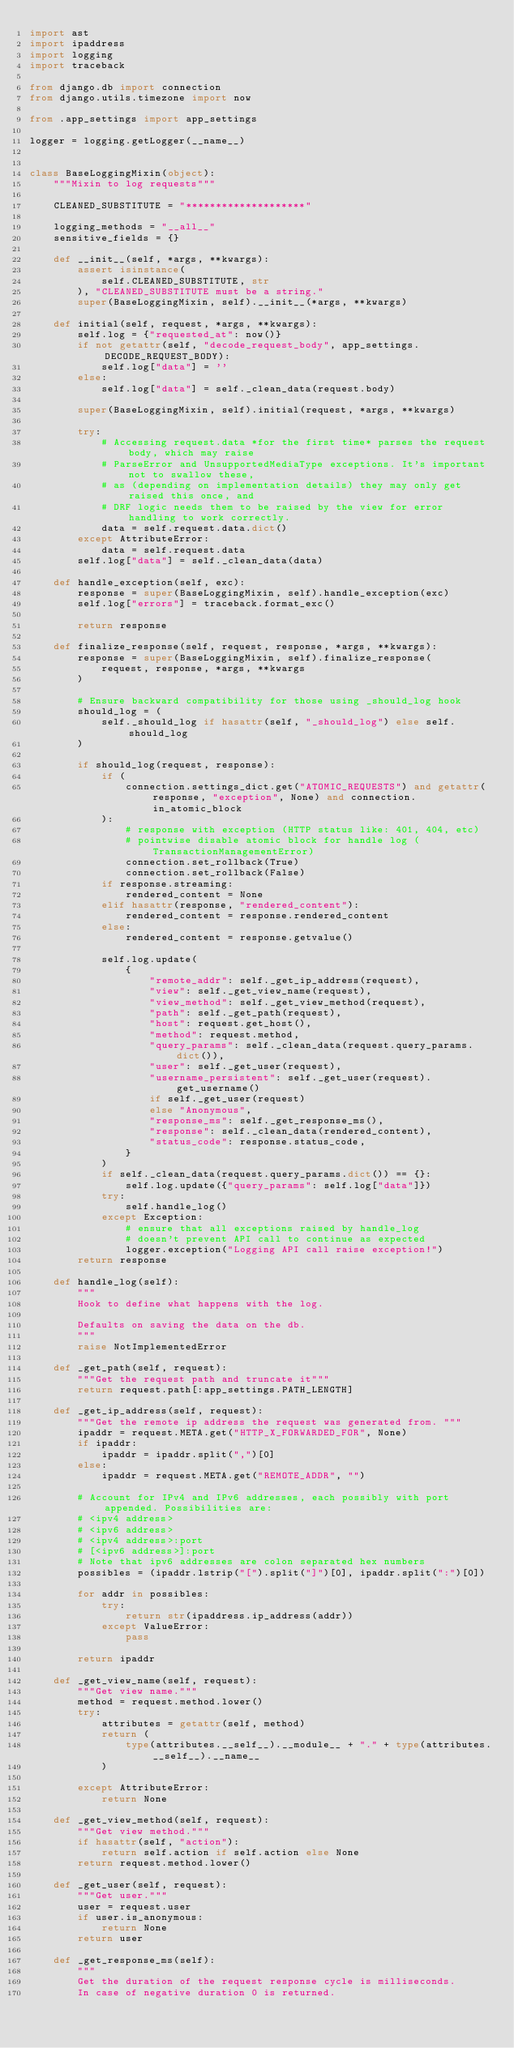<code> <loc_0><loc_0><loc_500><loc_500><_Python_>import ast
import ipaddress
import logging
import traceback

from django.db import connection
from django.utils.timezone import now

from .app_settings import app_settings

logger = logging.getLogger(__name__)


class BaseLoggingMixin(object):
    """Mixin to log requests"""

    CLEANED_SUBSTITUTE = "********************"

    logging_methods = "__all__"
    sensitive_fields = {}

    def __init__(self, *args, **kwargs):
        assert isinstance(
            self.CLEANED_SUBSTITUTE, str
        ), "CLEANED_SUBSTITUTE must be a string."
        super(BaseLoggingMixin, self).__init__(*args, **kwargs)

    def initial(self, request, *args, **kwargs):
        self.log = {"requested_at": now()}
        if not getattr(self, "decode_request_body", app_settings.DECODE_REQUEST_BODY):
            self.log["data"] = ''
        else:
            self.log["data"] = self._clean_data(request.body)

        super(BaseLoggingMixin, self).initial(request, *args, **kwargs)

        try:
            # Accessing request.data *for the first time* parses the request body, which may raise
            # ParseError and UnsupportedMediaType exceptions. It's important not to swallow these,
            # as (depending on implementation details) they may only get raised this once, and
            # DRF logic needs them to be raised by the view for error handling to work correctly.
            data = self.request.data.dict()
        except AttributeError:
            data = self.request.data
        self.log["data"] = self._clean_data(data)

    def handle_exception(self, exc):
        response = super(BaseLoggingMixin, self).handle_exception(exc)
        self.log["errors"] = traceback.format_exc()

        return response

    def finalize_response(self, request, response, *args, **kwargs):
        response = super(BaseLoggingMixin, self).finalize_response(
            request, response, *args, **kwargs
        )

        # Ensure backward compatibility for those using _should_log hook
        should_log = (
            self._should_log if hasattr(self, "_should_log") else self.should_log
        )

        if should_log(request, response):
            if (
                connection.settings_dict.get("ATOMIC_REQUESTS") and getattr(response, "exception", None) and connection.in_atomic_block
            ):
                # response with exception (HTTP status like: 401, 404, etc)
                # pointwise disable atomic block for handle log (TransactionManagementError)
                connection.set_rollback(True)
                connection.set_rollback(False)
            if response.streaming:
                rendered_content = None
            elif hasattr(response, "rendered_content"):
                rendered_content = response.rendered_content
            else:
                rendered_content = response.getvalue()

            self.log.update(
                {
                    "remote_addr": self._get_ip_address(request),
                    "view": self._get_view_name(request),
                    "view_method": self._get_view_method(request),
                    "path": self._get_path(request),
                    "host": request.get_host(),
                    "method": request.method,
                    "query_params": self._clean_data(request.query_params.dict()),
                    "user": self._get_user(request),
                    "username_persistent": self._get_user(request).get_username()
                    if self._get_user(request)
                    else "Anonymous",
                    "response_ms": self._get_response_ms(),
                    "response": self._clean_data(rendered_content),
                    "status_code": response.status_code,
                }
            )
            if self._clean_data(request.query_params.dict()) == {}:
                self.log.update({"query_params": self.log["data"]})
            try:
                self.handle_log()
            except Exception:
                # ensure that all exceptions raised by handle_log
                # doesn't prevent API call to continue as expected
                logger.exception("Logging API call raise exception!")
        return response

    def handle_log(self):
        """
        Hook to define what happens with the log.

        Defaults on saving the data on the db.
        """
        raise NotImplementedError

    def _get_path(self, request):
        """Get the request path and truncate it"""
        return request.path[:app_settings.PATH_LENGTH]

    def _get_ip_address(self, request):
        """Get the remote ip address the request was generated from. """
        ipaddr = request.META.get("HTTP_X_FORWARDED_FOR", None)
        if ipaddr:
            ipaddr = ipaddr.split(",")[0]
        else:
            ipaddr = request.META.get("REMOTE_ADDR", "")

        # Account for IPv4 and IPv6 addresses, each possibly with port appended. Possibilities are:
        # <ipv4 address>
        # <ipv6 address>
        # <ipv4 address>:port
        # [<ipv6 address>]:port
        # Note that ipv6 addresses are colon separated hex numbers
        possibles = (ipaddr.lstrip("[").split("]")[0], ipaddr.split(":")[0])

        for addr in possibles:
            try:
                return str(ipaddress.ip_address(addr))
            except ValueError:
                pass

        return ipaddr

    def _get_view_name(self, request):
        """Get view name."""
        method = request.method.lower()
        try:
            attributes = getattr(self, method)
            return (
                type(attributes.__self__).__module__ + "." + type(attributes.__self__).__name__
            )

        except AttributeError:
            return None

    def _get_view_method(self, request):
        """Get view method."""
        if hasattr(self, "action"):
            return self.action if self.action else None
        return request.method.lower()

    def _get_user(self, request):
        """Get user."""
        user = request.user
        if user.is_anonymous:
            return None
        return user

    def _get_response_ms(self):
        """
        Get the duration of the request response cycle is milliseconds.
        In case of negative duration 0 is returned.</code> 